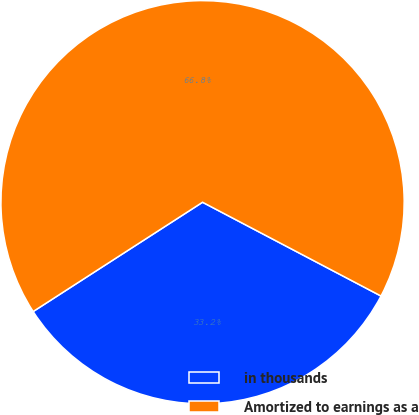<chart> <loc_0><loc_0><loc_500><loc_500><pie_chart><fcel>in thousands<fcel>Amortized to earnings as a<nl><fcel>33.18%<fcel>66.82%<nl></chart> 